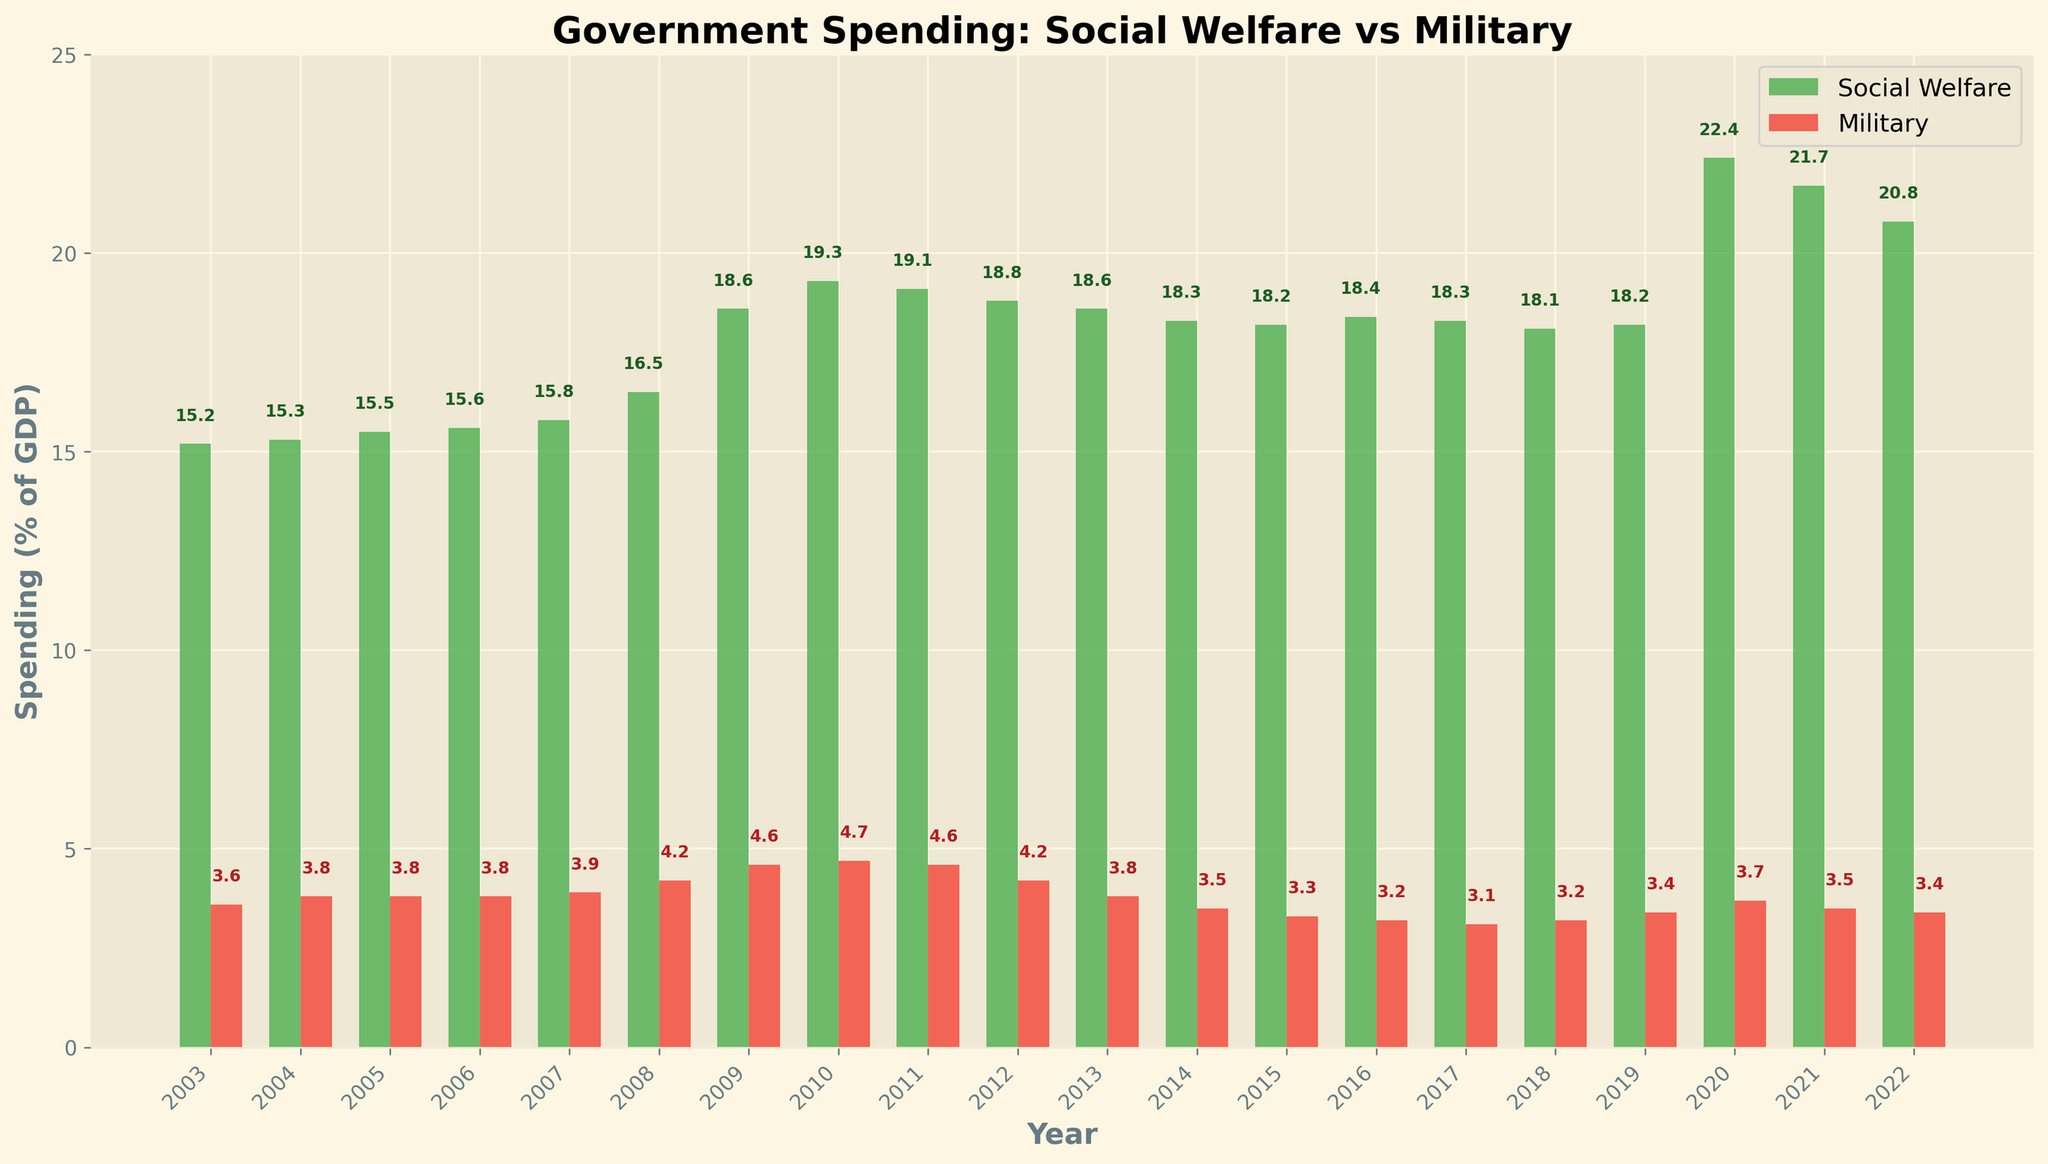What year had the highest social welfare spending as a percentage of GDP? Look for the tallest green bar in the chart.
Answer: 2020 What is the difference in social welfare spending and military spending in 2010? Identify the heights of the bars for 2010. Subtract the percentage of military spending from social welfare spending: 19.3 - 4.7 = 14.6
Answer: 14.6 Between which two consecutive years did social welfare spending increase the most? Compare the increase in the heights of green bars between each pair of consecutive years. The largest increase occurred between 2019 and 2020 (18.2 to 22.4, an increase of 4.2).
Answer: 2019 and 2020 On average, how much of the GDP was spent on military per year over the last 20 years? Sum the values of military spending across all years and divide by the number of years. (3.6 + 3.8 + 3.8 + 3.8 + 3.9 + 4.2 + 4.6 + 4.7 + 4.6 + 4.2 + 3.8 + 3.5 + 3.3 + 3.2 + 3.1 + 3.2 + 3.4 + 3.7 + 3.5 + 3.4) / 20 = 3.75
Answer: 3.75 What is the trend of military spending compared to social welfare spending between 2008 and 2012? Observe the heights of red and green bars from 2008 to 2012. Military spending increased to 4.7 in 2010 and then decreased to 4.2 by 2012. Social welfare spending peaked in 2010 and then slightly decreased.
Answer: Military decreased after 2010, Social welfare increased till 2010 then decreased Which year saw the smallest difference in social welfare and military spending? Calculate the difference between the green and red bars for each year and find the minimum. The smallest difference is in 2018: 18.1 - 3.2 = 14.9.
Answer: 2018 What is the color of the bar representing military spending? The bars representing military spending are red.
Answer: Red How does social welfare spending in 2022 compare to that in 2003? Compare the heights of the green bars in 2022 and 2003. In 2022, social welfare spending is 20.8 and in 2003 it is 15.2, indicating an increase.
Answer: Increased Calculate the average social welfare spending over the specified period. Sum all the values of social welfare spending and divide by the number of years. (15.2 + 15.3 + 15.5 + 15.6 + 15.8 + 16.5 + 18.6 + 19.3 + 19.1 + 18.8 + 18.6 + 18.3 + 18.2 + 18.4 + 18.3 + 18.1 + 18.2 + 22.4 + 21.7 + 20.8) / 20 ≈ 18.1
Answer: 18.1 Is there any year where military spending exceeded social welfare spending? Examine the heights of the bars; the red bars never exceed the green bars in any year.
Answer: No 